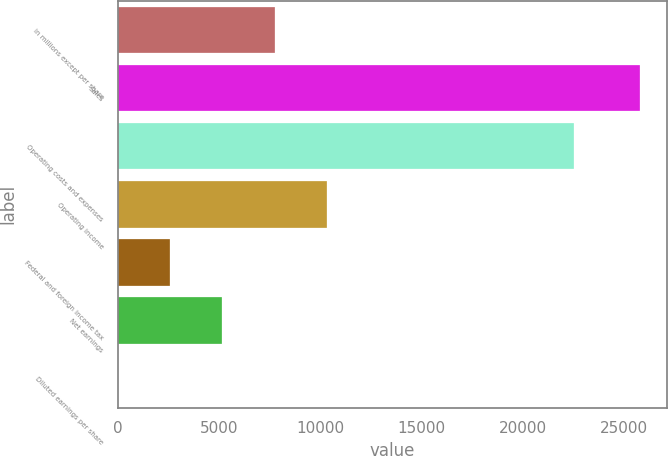<chart> <loc_0><loc_0><loc_500><loc_500><bar_chart><fcel>in millions except per share<fcel>Sales<fcel>Operating costs and expenses<fcel>Operating income<fcel>Federal and foreign income tax<fcel>Net earnings<fcel>Diluted earnings per share<nl><fcel>7748.92<fcel>25803<fcel>22504<fcel>10328.1<fcel>2590.62<fcel>5169.77<fcel>11.47<nl></chart> 